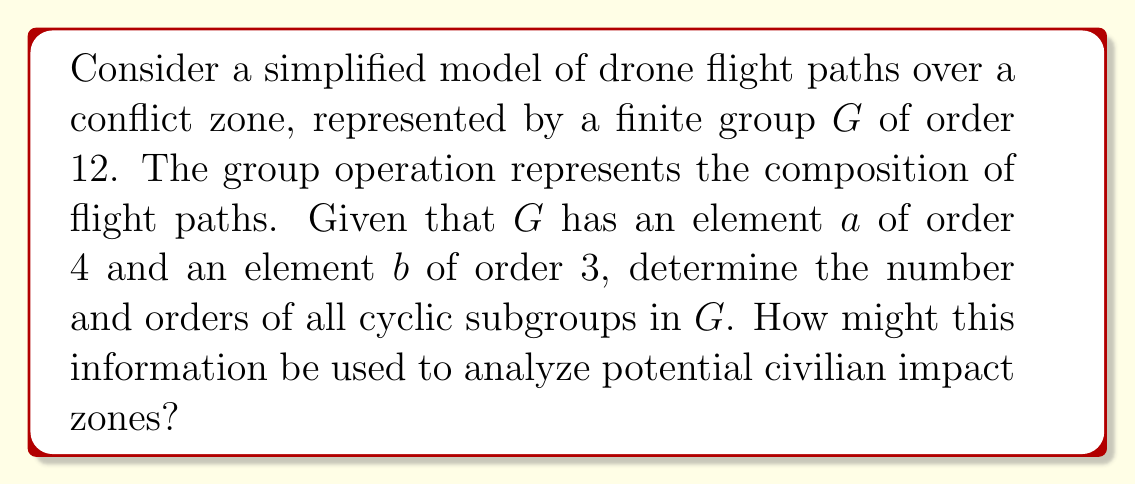Teach me how to tackle this problem. Let's approach this step-by-step:

1) First, we need to understand the structure of $G$. Given the information, $G$ is likely isomorphic to $A_4$ (the alternating group on 4 elements) or $D_{12}$ (the dihedral group of order 12).

2) To find all cyclic subgroups, we need to consider all possible orders of elements in $G$. By Lagrange's theorem, the order of any element must divide the order of the group. So, the possible orders are 1, 2, 3, 4, 6, and 12.

3) Let's analyze each order:
   - Order 1: The identity element $e$ always forms a cyclic subgroup $\{e\}$ of order 1.
   - Order 2: There must be at least two elements of order 2 (because $a^2$ has order 2).
   - Order 3: We're given that $b$ has order 3, so $\langle b \rangle$ is a cyclic subgroup of order 3.
   - Order 4: We're given that $a$ has order 4, so $\langle a \rangle$ is a cyclic subgroup of order 4.
   - Order 6: There are no elements of order 6 because neither $A_4$ nor $D_{12}$ have elements of order 6.
   - Order 12: There are no elements of order 12 because neither $A_4$ nor $D_{12}$ have elements of order 12.

4) In both $A_4$ and $D_{12}$, there are:
   - 1 subgroup of order 1
   - 3 subgroups of order 2
   - 4 subgroups of order 3
   - 1 subgroup of order 4

5) Therefore, there are 9 cyclic subgroups in total.

6) For analyzing civilian impact zones:
   - Subgroups of order 2 could represent back-and-forth paths.
   - Subgroups of order 3 could represent triangular flight patterns.
   - The subgroup of order 4 could represent square or rectangular flight patterns.
   Understanding these patterns could help predict areas of frequent drone presence and potential strike zones, aiding in civilian protection efforts.
Answer: There are 9 cyclic subgroups in $G$:
- 1 of order 1
- 3 of order 2
- 4 of order 3
- 1 of order 4
This structure can be used to analyze potential civilian impact zones by identifying common flight patterns and areas of frequent drone presence. 